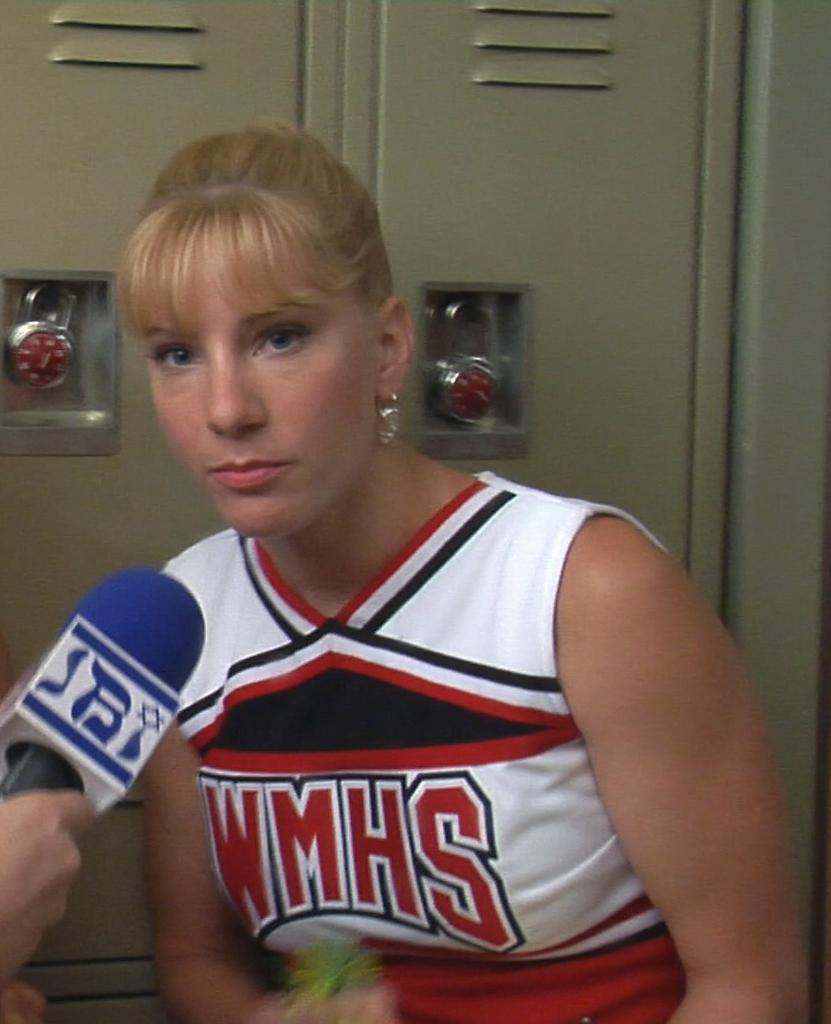<image>
Create a compact narrative representing the image presented. A blonde woman in a locker room has a microphone near her and is wearing a cheerleaders outfit with WMHS on it. 